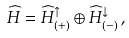<formula> <loc_0><loc_0><loc_500><loc_500>\widehat { H } = \widehat { H } _ { ( + ) } ^ { \uparrow } \oplus \widehat { H } _ { ( - ) } ^ { \downarrow } \, ,</formula> 